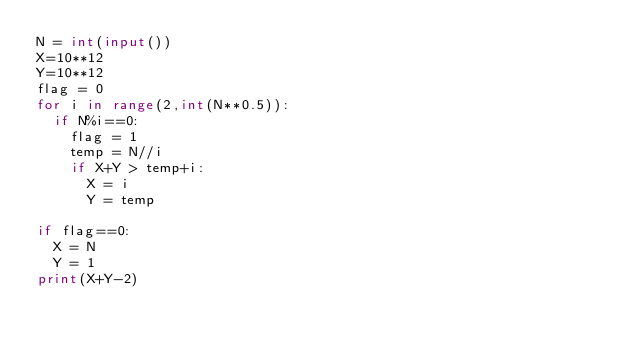<code> <loc_0><loc_0><loc_500><loc_500><_Python_>N = int(input())
X=10**12
Y=10**12
flag = 0
for i in range(2,int(N**0.5)):
  if N%i==0:
    flag = 1
    temp = N//i
    if X+Y > temp+i:
      X = i
      Y = temp
      
if flag==0:
  X = N
  Y = 1
print(X+Y-2)</code> 